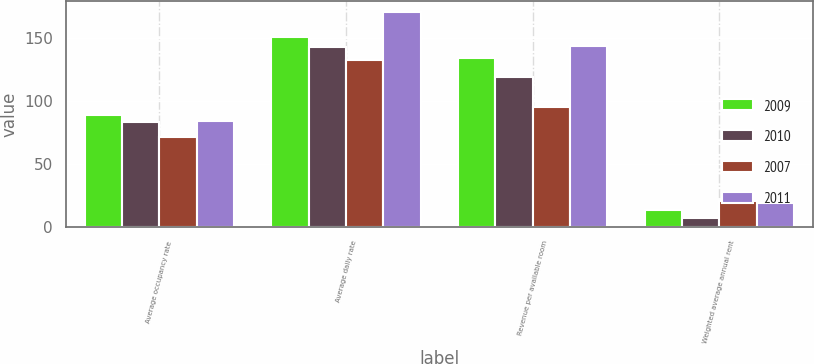Convert chart to OTSL. <chart><loc_0><loc_0><loc_500><loc_500><stacked_bar_chart><ecel><fcel>Average occupancy rate<fcel>Average daily rate<fcel>Revenue per available room<fcel>Weighted average annual rent<nl><fcel>2009<fcel>89.1<fcel>150.91<fcel>134.43<fcel>13.49<nl><fcel>2010<fcel>83.2<fcel>143.28<fcel>119.23<fcel>7.52<nl><fcel>2007<fcel>71.5<fcel>133.2<fcel>95.18<fcel>20.54<nl><fcel>2011<fcel>84.1<fcel>171.32<fcel>144.01<fcel>18.78<nl></chart> 